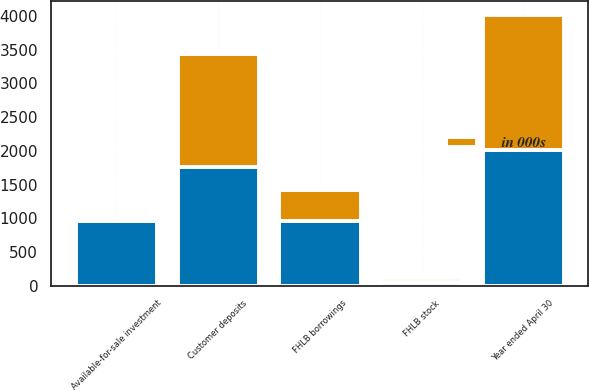<chart> <loc_0><loc_0><loc_500><loc_500><stacked_bar_chart><ecel><fcel>Year ended April 30<fcel>Available-for-sale investment<fcel>FHLB stock<fcel>Customer deposits<fcel>FHLB borrowings<nl><fcel>nan<fcel>2012<fcel>954<fcel>58<fcel>1753<fcel>954<nl><fcel>in 000s<fcel>2011<fcel>7<fcel>52<fcel>1686<fcel>471<nl></chart> 